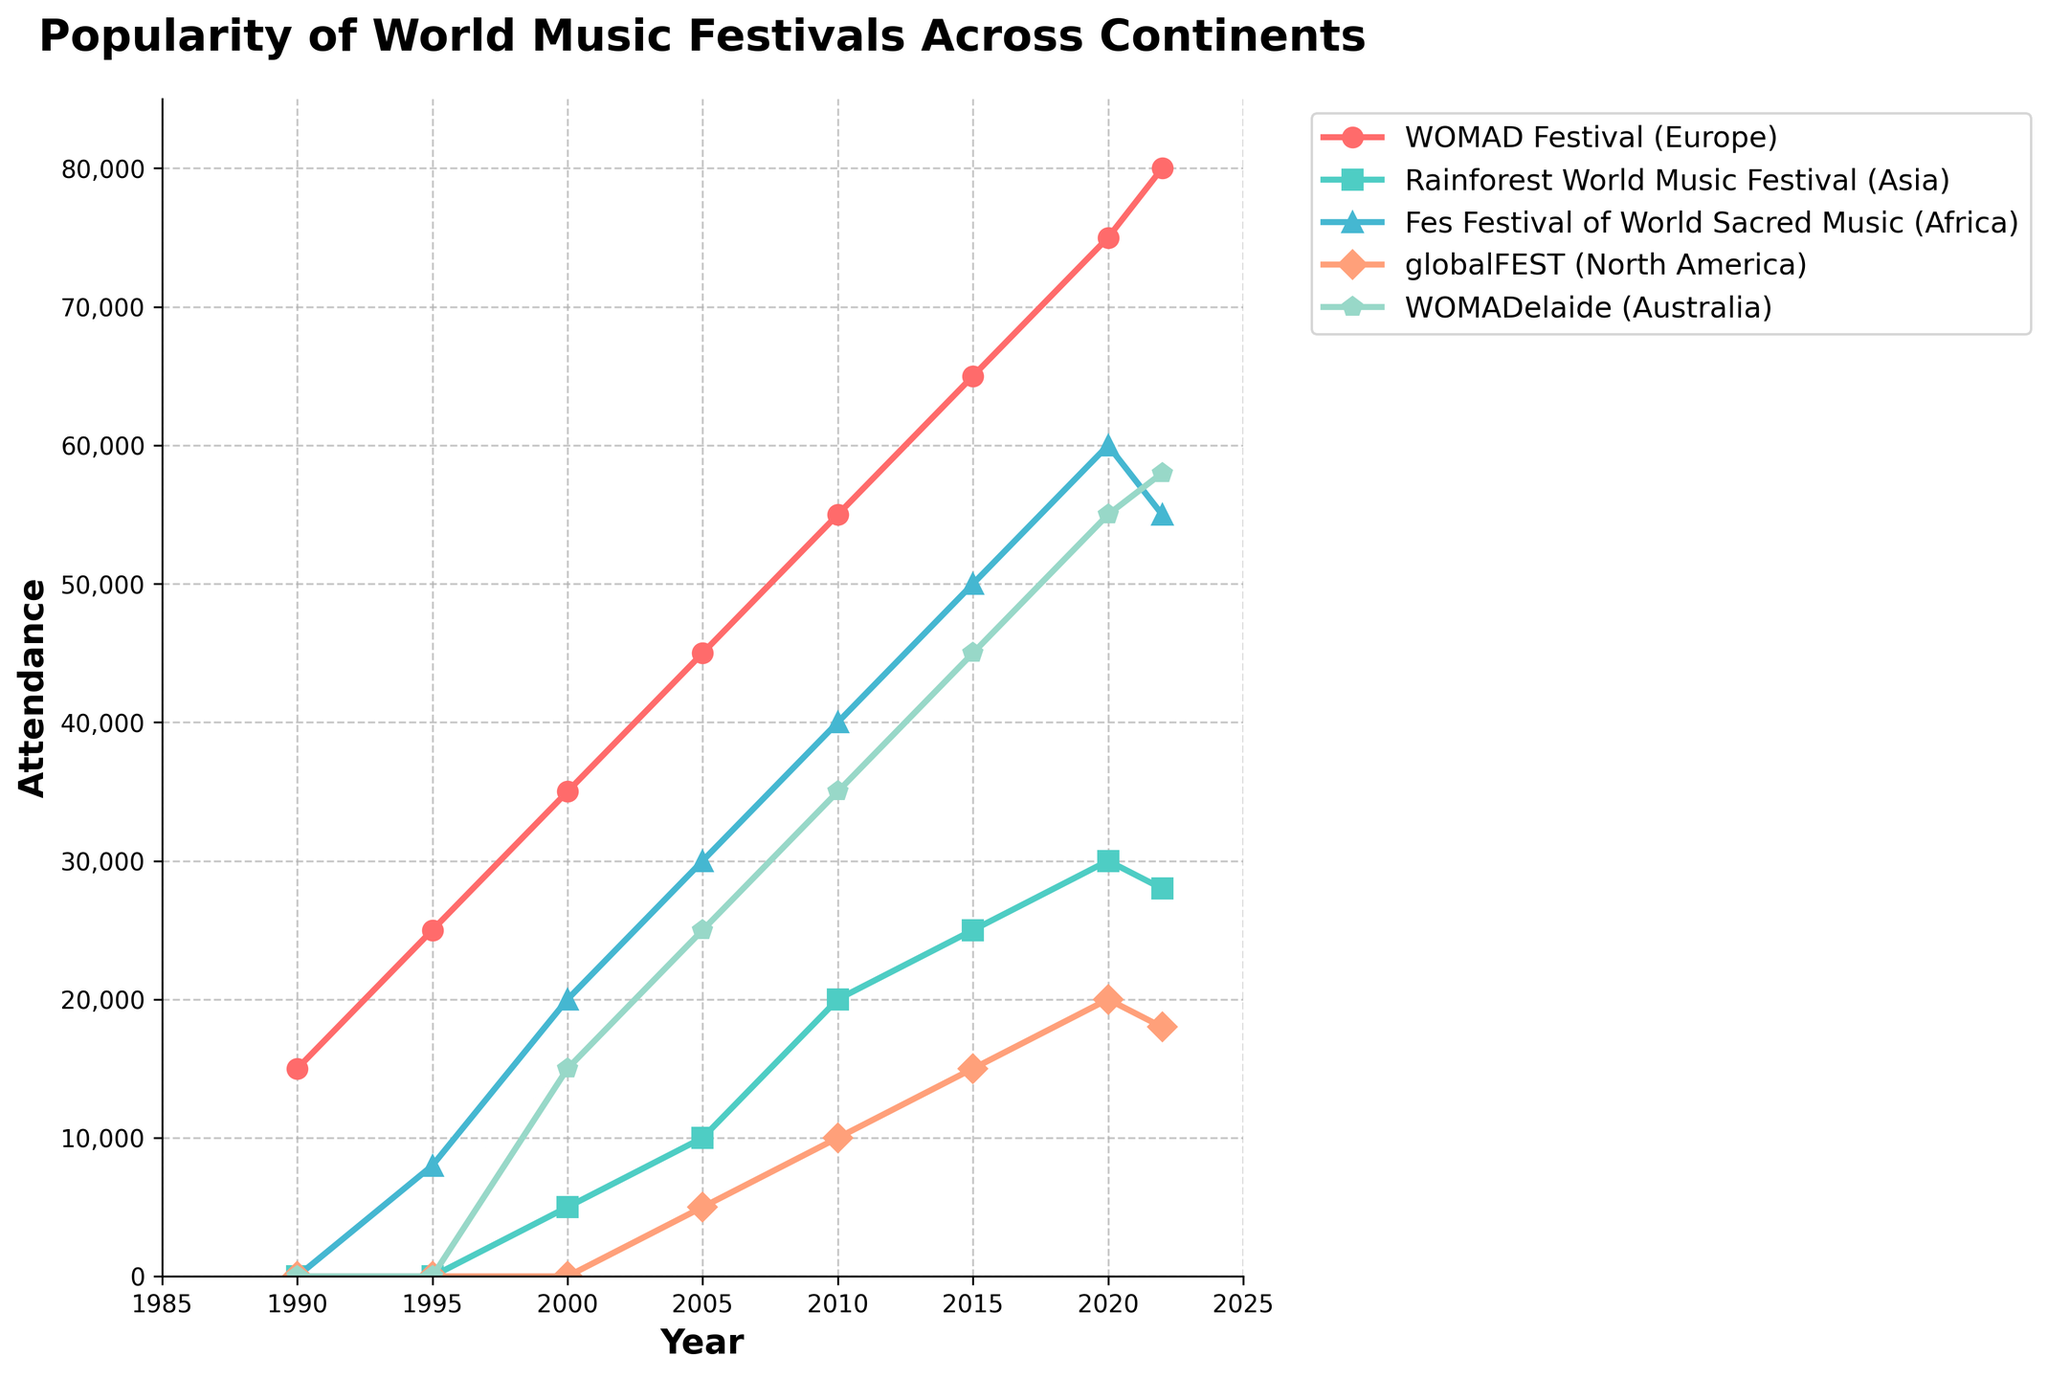What is the trend of attendance at the WOMAD Festival (Europe) from 1990 to 2022? The attendance at the WOMAD Festival (Europe) shows a consistent upward trend from 15,000 in 1990 to 80,000 in 2022. Each recorded year shows an increase in attendance.
Answer: Upward trend Which festival had no attendance before the year 2000? The data shows that both the Rainforest World Music Festival (Asia) and the Fes Festival of World Sacred Music (Africa) had no attendance recorded before 2000. The globalFEST (North America) and WOMADelaide (Australia) also had no attendance before 2000.
Answer: Rainforest World Music Festival, Fes Festival of World Sacred Music, globalFEST, WOMADelaide By how much did the attendance for the Rainforest World Music Festival (Asia) increase from 2000 to 2020? The attendance in 2000 was 5,000, and it increased to 30,000 by 2020. The difference is 30,000 - 5,000 = 25,000.
Answer: 25,000 Compare the popularity of WOMADelaide (Australia) and globalFEST (North America) in 2022. Which one had higher attendance and by how much? In 2022, WOMADelaide had an attendance of 58,000 while globalFEST had 18,000. The difference in attendance is 58,000 - 18,000 = 40,000, with WOMADelaide being higher.
Answer: WOMADelaide by 40,000 Which festival had the largest growth in attendance between 2010 and 2020? Comparing the attendance figures for each festival in 2010 and 2020: WOMAD Festival (Europe) grew from 55,000 to 75,000 (20,000 increase), Rainforest World Music Festival (Asia) from 20,000 to 30,000 (10,000 increase), Fes Festival of World Sacred Music (Africa) from 40,000 to 60,000 (20,000 increase), globalFEST (North America) from 10,000 to 20,000 (10,000 increase), and WOMADelaide (Australia) from 35,000 to 55,000 (20,000 increase). All festivals except the Rainforest and globalFEST had the same largest growth of 20,000.
Answer: WOMAD Festival, Fes Festival, WOMADelaide In what year did the Fes Festival of World Sacred Music (Africa) surpass 50,000 attendees? According to the data, the Fes Festival of World Sacred Music surpassed 50,000 attendees in the year 2015 when it recorded 50,000 attendees.
Answer: 2015 What color represents the WOMAD Festival (Europe) in the plot? The color representing the WOMAD Festival (Europe) in the plot is red. This is based on visual inspection of the legend corresponding to the line color for the festival.
Answer: Red 